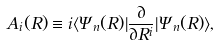<formula> <loc_0><loc_0><loc_500><loc_500>A _ { i } ( R ) \equiv i \langle \Psi _ { n } ( R ) | \frac { \partial } { \partial R ^ { i } } | \Psi _ { n } ( R ) \rangle ,</formula> 